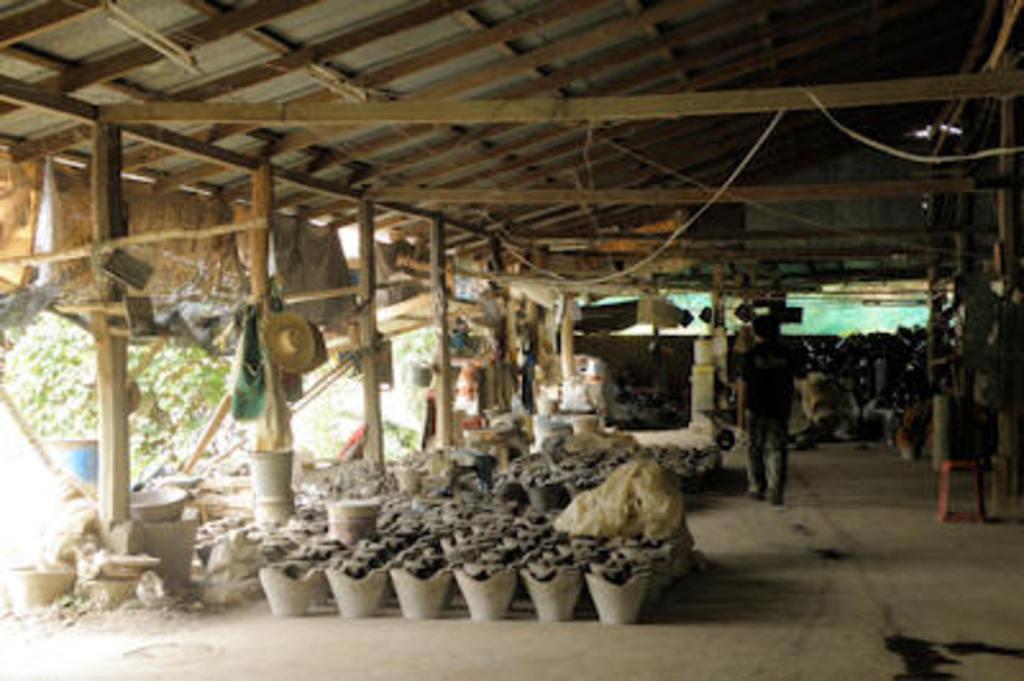Describe this image in one or two sentences. In this image there is one person standing and there are some buckets, and in the buckets there are some object and also we could see some baskets, bags, stool, towers, clothes, hats, wooden pillars and some other objects. At the bottom there is floor, and in the background there are trees and drum. At the top there is ceiling and some wooden poles and ropes. 